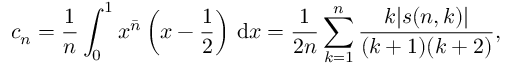Convert formula to latex. <formula><loc_0><loc_0><loc_500><loc_500>c _ { n } = { \frac { 1 } { n } } \int _ { 0 } ^ { 1 } x ^ { \bar { n } } \left ( x - { \frac { 1 } { 2 } } \right ) \, { d } x = { \frac { 1 } { 2 n } } \sum _ { k = 1 } ^ { n } { \frac { k | s ( n , k ) | } { ( k + 1 ) ( k + 2 ) } } ,</formula> 